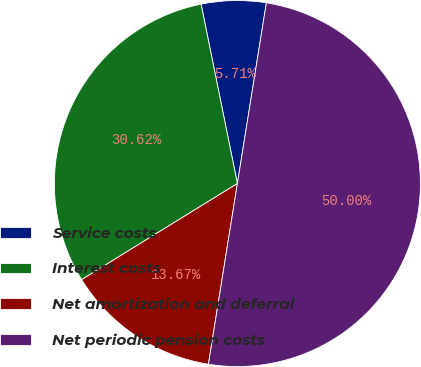Convert chart. <chart><loc_0><loc_0><loc_500><loc_500><pie_chart><fcel>Service costs<fcel>Interest costs<fcel>Net amortization and deferral<fcel>Net periodic pension costs<nl><fcel>5.71%<fcel>30.62%<fcel>13.67%<fcel>50.0%<nl></chart> 